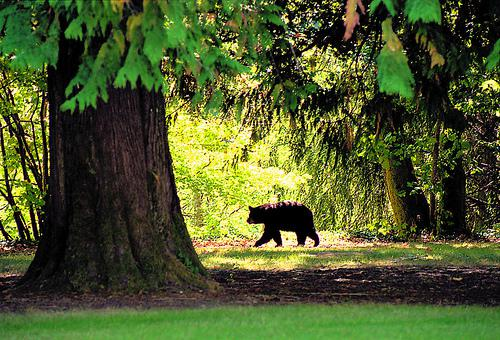Question: who is in the picture?
Choices:
A. Cat.
B. Skateboarder.
C. The bear.
D. Steward.
Answer with the letter. Answer: C Question: what the bear is doing?
Choices:
A. Eating.
B. Sleeping.
C. Walking.
D. Climbing.
Answer with the letter. Answer: C Question: how many people are in the picture?
Choices:
A. One.
B. Two.
C. Three.
D. None.
Answer with the letter. Answer: D Question: where this picture was taken?
Choices:
A. In a park.
B. In a city.
C. In a forest.
D. On a mountain.
Answer with the letter. Answer: C 